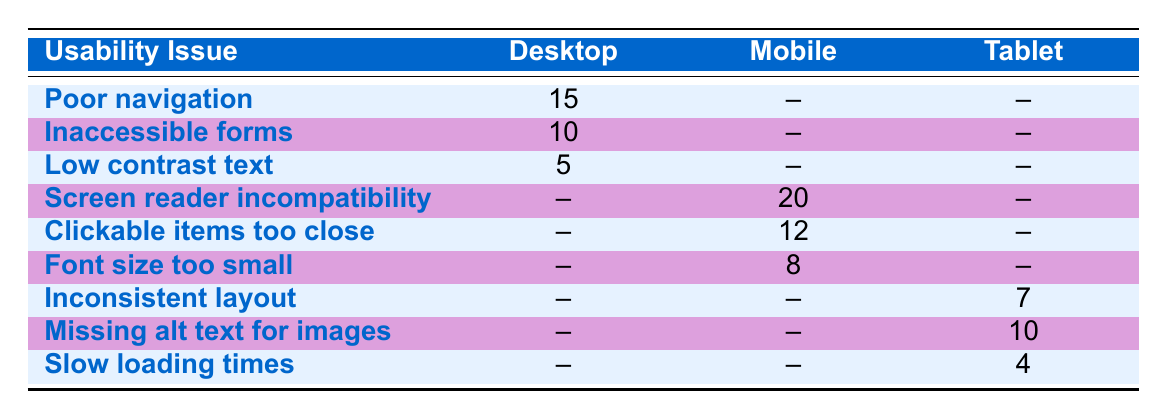What is the reported count of "Poor navigation" issues for Desktop users? "Poor navigation" is listed under the Desktop device category with a reported count of 15.
Answer: 15 How many reported issues are related to Mobile users? To find the total for Mobile users, we add the reported counts: 20 (screen reader incompatibility) + 12 (clickable items too close) + 8 (font size too small) = 40.
Answer: 40 Is there any reported issue for Tablet users regarding "Slow loading times"? "Slow loading times" is displayed under the Tablet category with a reported count of 4. Hence, the answer is yes.
Answer: Yes Which device type has the highest reported count of accessibility issues? From the analysis of reported counts, Mobile has a total of 40, Desktop has a total of 30 (15 + 10 + 5), and Tablet has a total of 21 (7 + 10 + 4). Mobile has the highest reported count.
Answer: Mobile What is the total number of accessibility issues reported across all device types? To find the total, we sum all reported counts: 15 (Desktop) + 10 (Desktop) + 5 (Desktop) + 20 (Mobile) + 12 (Mobile) + 8 (Mobile) + 7 (Tablet) + 10 (Tablet) + 4 (Tablet) = 91.
Answer: 91 How many more issues were reported for Mobile users than for Desktop users? Mobile users reported 40 issues, while Desktop users reported 30. The difference is 40 - 30 = 10.
Answer: 10 Are there any usability issues reported for Desktop users that are also reported for Mobile users? No usability issues listed under Desktop are also listed for Mobile; thus, the answer is no.
Answer: No What is the average reported count of usability issues per device type? The total reported counts are 91 for all users across 3 device types, so the average is 91 / 3 = 30.33.
Answer: 30.33 